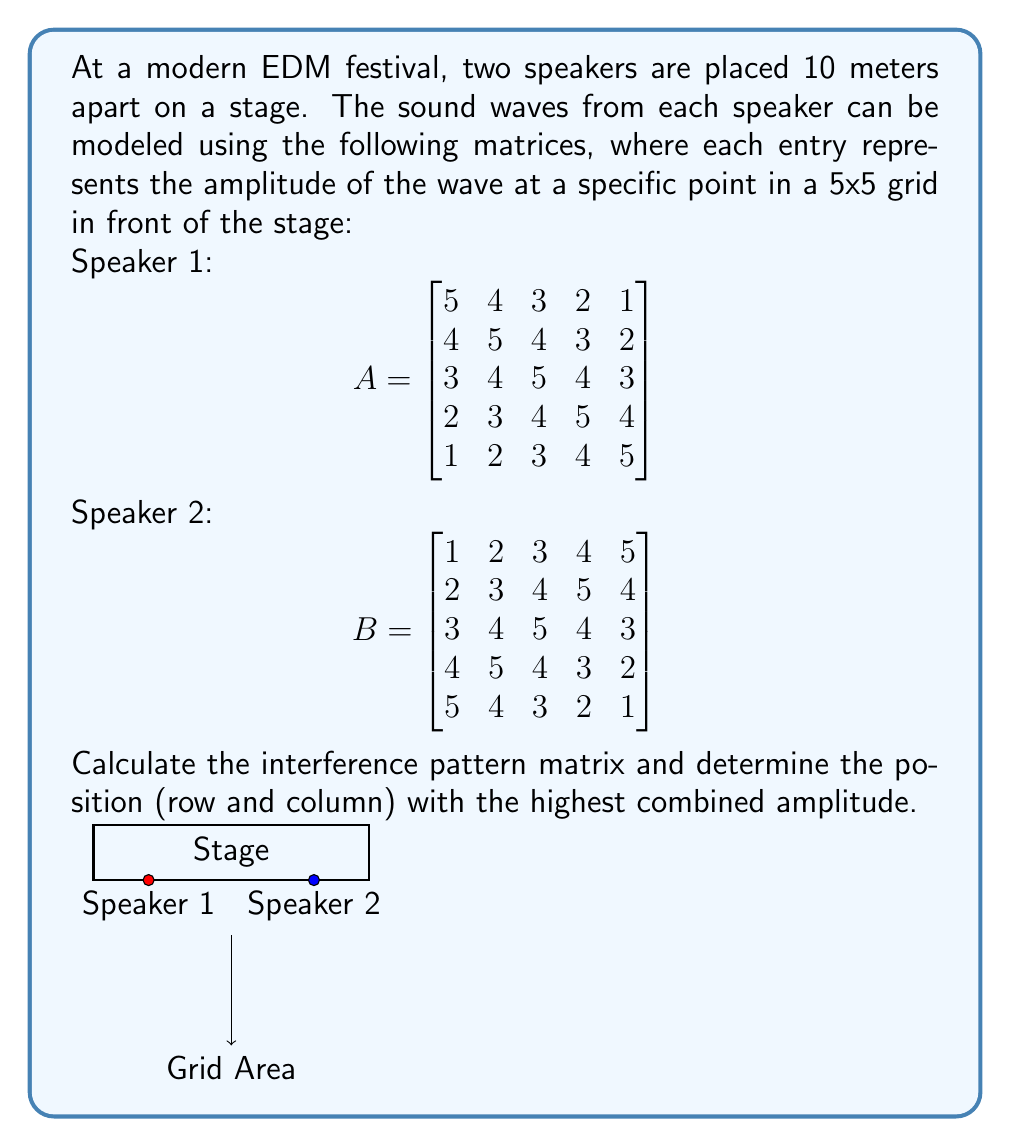Solve this math problem. To solve this problem, we'll follow these steps:

1) First, we need to calculate the interference pattern matrix. In sound wave interference, the amplitudes add up. So, we'll add matrices A and B:

   $$C = A + B = \begin{bmatrix}
   6 & 6 & 6 & 6 & 6 \\
   6 & 8 & 8 & 8 & 6 \\
   6 & 8 & 10 & 8 & 6 \\
   6 & 8 & 8 & 8 & 6 \\
   6 & 6 & 6 & 6 & 6
   \end{bmatrix}$$

2) Now, we need to find the highest value in this matrix C, which represents the position with the highest combined amplitude.

3) Inspecting the matrix, we can see that the highest value is 10.

4) This value appears in the center of the matrix, which is at position (3,3) if we're using 1-based indexing (row 3, column 3).

Therefore, the position with the highest combined amplitude is at the center of the grid, represented by row 3, column 3 in the interference pattern matrix.
Answer: (3,3) 